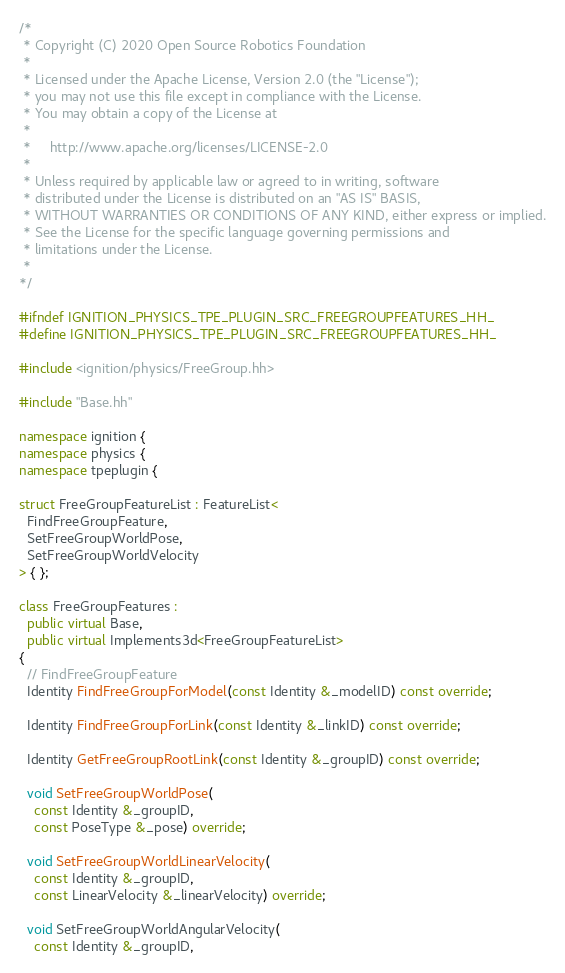Convert code to text. <code><loc_0><loc_0><loc_500><loc_500><_C++_>/*
 * Copyright (C) 2020 Open Source Robotics Foundation
 *
 * Licensed under the Apache License, Version 2.0 (the "License");
 * you may not use this file except in compliance with the License.
 * You may obtain a copy of the License at
 *
 *     http://www.apache.org/licenses/LICENSE-2.0
 *
 * Unless required by applicable law or agreed to in writing, software
 * distributed under the License is distributed on an "AS IS" BASIS,
 * WITHOUT WARRANTIES OR CONDITIONS OF ANY KIND, either express or implied.
 * See the License for the specific language governing permissions and
 * limitations under the License.
 *
*/

#ifndef IGNITION_PHYSICS_TPE_PLUGIN_SRC_FREEGROUPFEATURES_HH_
#define IGNITION_PHYSICS_TPE_PLUGIN_SRC_FREEGROUPFEATURES_HH_

#include <ignition/physics/FreeGroup.hh>

#include "Base.hh"

namespace ignition {
namespace physics {
namespace tpeplugin {

struct FreeGroupFeatureList : FeatureList<
  FindFreeGroupFeature,
  SetFreeGroupWorldPose,
  SetFreeGroupWorldVelocity
> { };

class FreeGroupFeatures :
  public virtual Base,
  public virtual Implements3d<FreeGroupFeatureList>
{
  // FindFreeGroupFeature
  Identity FindFreeGroupForModel(const Identity &_modelID) const override;

  Identity FindFreeGroupForLink(const Identity &_linkID) const override;

  Identity GetFreeGroupRootLink(const Identity &_groupID) const override;

  void SetFreeGroupWorldPose(
    const Identity &_groupID,
    const PoseType &_pose) override;

  void SetFreeGroupWorldLinearVelocity(
    const Identity &_groupID,
    const LinearVelocity &_linearVelocity) override;

  void SetFreeGroupWorldAngularVelocity(
    const Identity &_groupID,</code> 